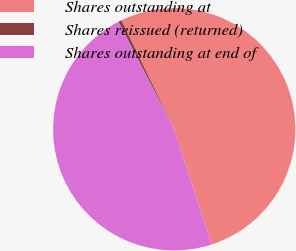Convert chart. <chart><loc_0><loc_0><loc_500><loc_500><pie_chart><fcel>Shares outstanding at<fcel>Shares reissued (returned)<fcel>Shares outstanding at end of<nl><fcel>52.2%<fcel>0.43%<fcel>47.37%<nl></chart> 